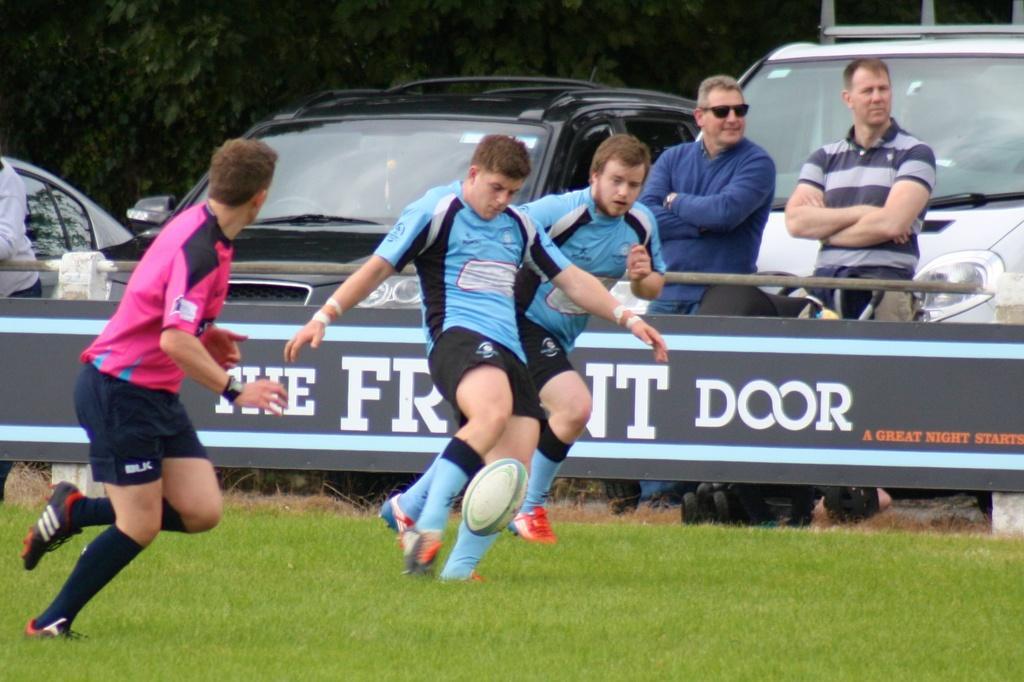Please provide a concise description of this image. The image is outside of the city. In the image there are three people playing a game and right side there are two people standing behind the car. In background there are some trees and at bottom there is a grass. 